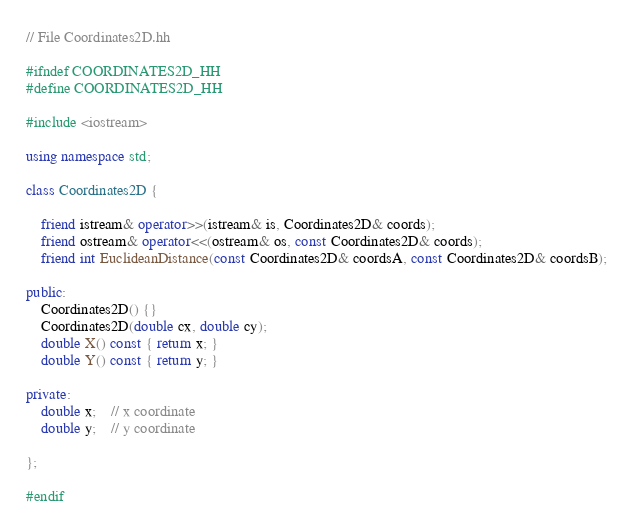Convert code to text. <code><loc_0><loc_0><loc_500><loc_500><_C++_>// File Coordinates2D.hh

#ifndef COORDINATES2D_HH
#define COORDINATES2D_HH

#include <iostream>

using namespace std;

class Coordinates2D {

	friend istream& operator>>(istream& is, Coordinates2D& coords);
	friend ostream& operator<<(ostream& os, const Coordinates2D& coords);
	friend int EuclideanDistance(const Coordinates2D& coordsA, const Coordinates2D& coordsB);

public:
	Coordinates2D() {}
	Coordinates2D(double cx, double cy);
	double X() const { return x; }
	double Y() const { return y; }

private:
	double x;	// x coordinate
	double y;	// y coordinate

};

#endif
</code> 